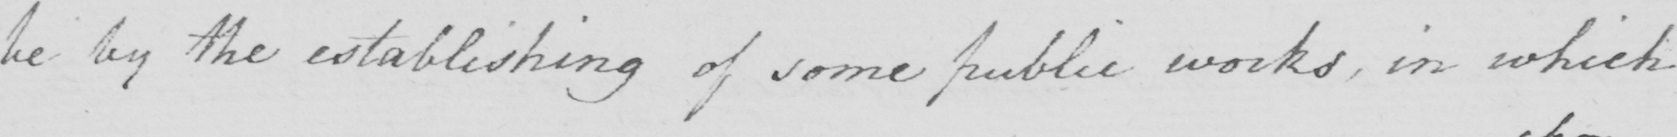What is written in this line of handwriting? be by the establishing of some pubic works , in which 